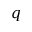Convert formula to latex. <formula><loc_0><loc_0><loc_500><loc_500>q</formula> 